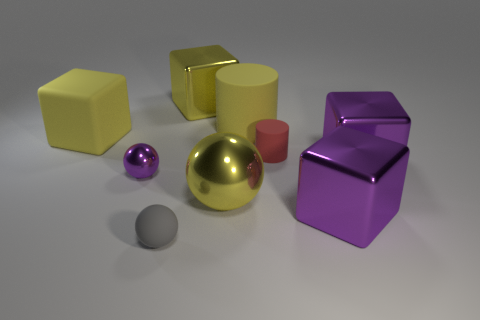Subtract all big yellow metal blocks. How many blocks are left? 3 Subtract all red cubes. Subtract all green balls. How many cubes are left? 4 Subtract all spheres. How many objects are left? 6 Add 5 big gray metallic cylinders. How many big gray metallic cylinders exist? 5 Subtract 1 yellow cylinders. How many objects are left? 8 Subtract all large metallic things. Subtract all gray rubber balls. How many objects are left? 4 Add 8 yellow metal blocks. How many yellow metal blocks are left? 9 